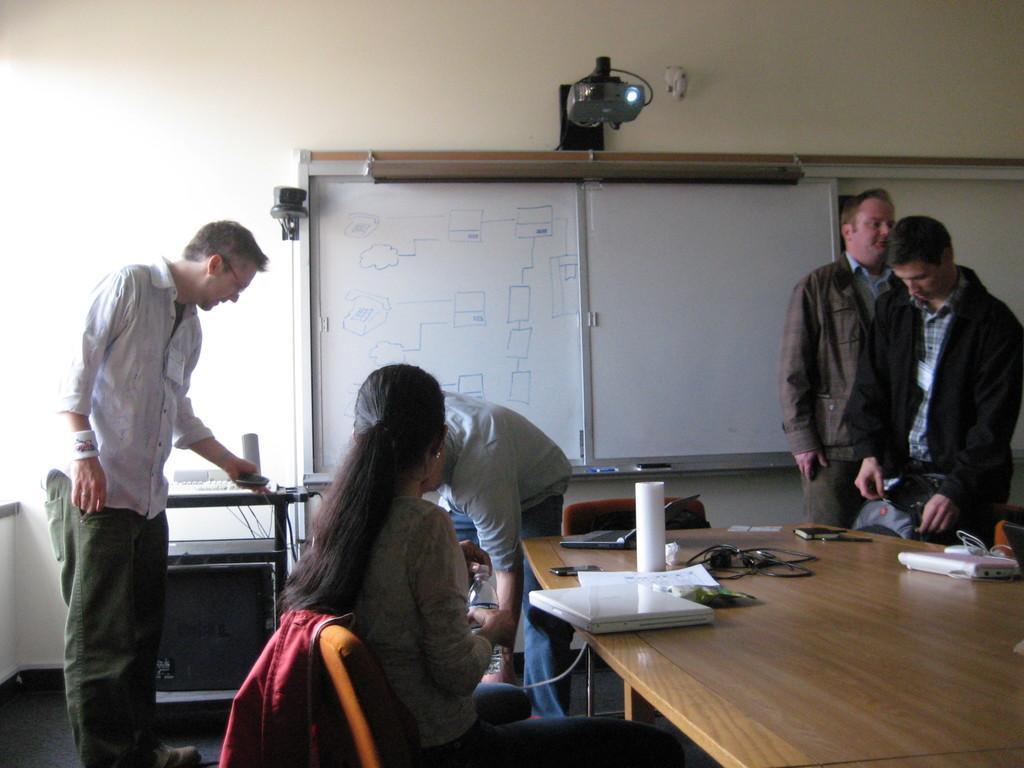Describe this image in one or two sentences. On this table there are laptops, bookmobile and objects. This woman is sitting on a chair. Here we can see four people. Above this whiteboard there is a projector. Beside this man there is a table. 